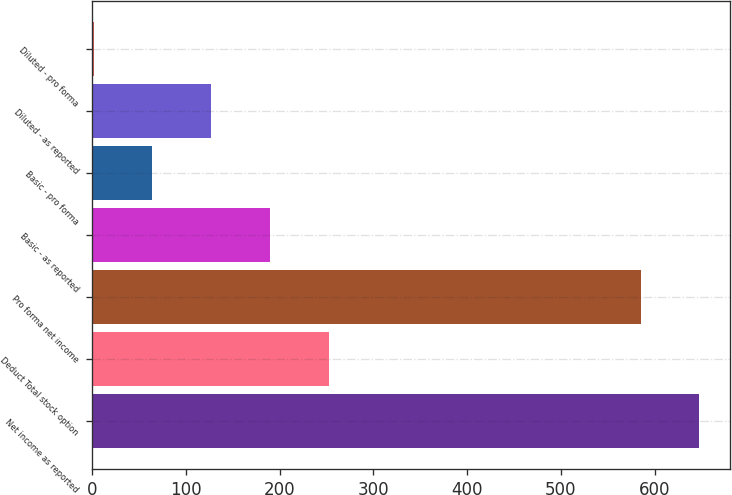<chart> <loc_0><loc_0><loc_500><loc_500><bar_chart><fcel>Net income as reported<fcel>Deduct Total stock option<fcel>Pro forma net income<fcel>Basic - as reported<fcel>Basic - pro forma<fcel>Diluted - as reported<fcel>Diluted - pro forma<nl><fcel>647.62<fcel>252.25<fcel>585<fcel>189.63<fcel>64.39<fcel>127.01<fcel>1.77<nl></chart> 